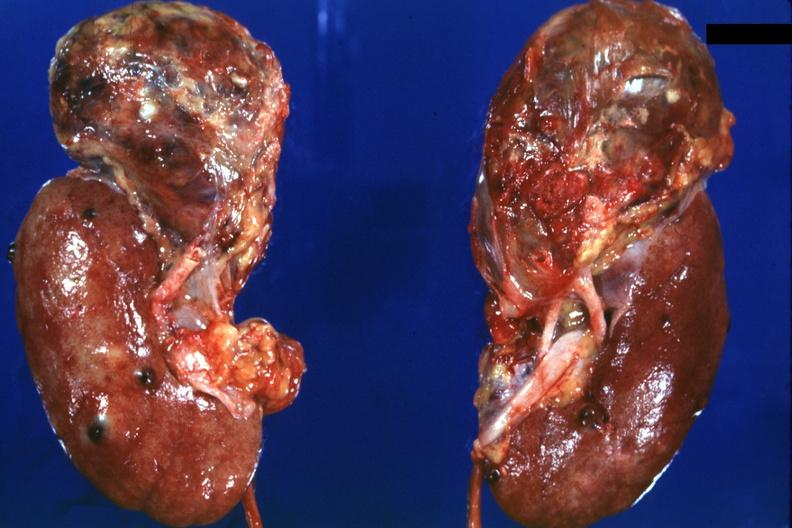what is present?
Answer the question using a single word or phrase. Renal cell carcinoma 